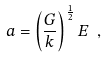Convert formula to latex. <formula><loc_0><loc_0><loc_500><loc_500>a = \left ( \frac { G } { k } \right ) ^ { \frac { 1 } { 2 } } E \ ,</formula> 